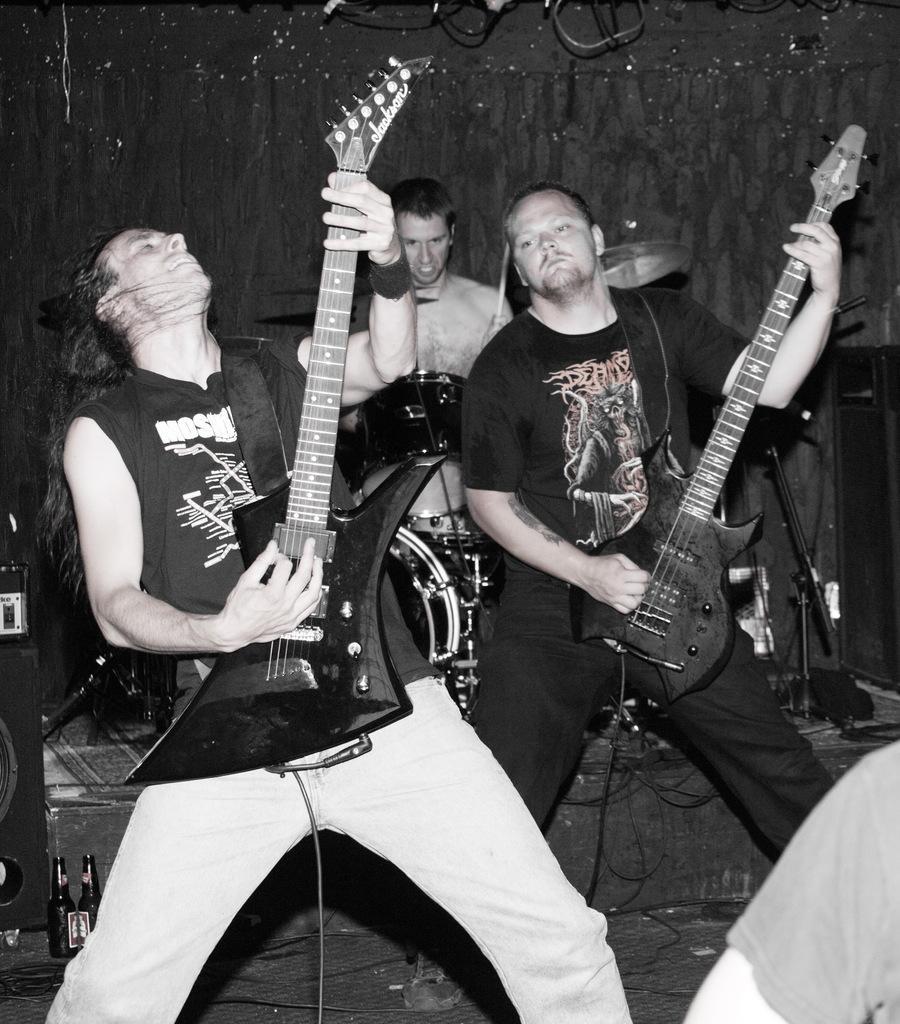Please provide a concise description of this image. In this image i can see three men playing the musical instrument, at the background i can see a wall. 